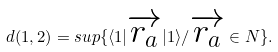<formula> <loc_0><loc_0><loc_500><loc_500>d ( 1 , 2 ) = s u p \{ \langle 1 | \overrightarrow { r _ { a } } | 1 \rangle / \overrightarrow { r _ { a } } \in N \} .</formula> 